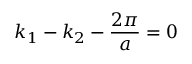Convert formula to latex. <formula><loc_0><loc_0><loc_500><loc_500>k _ { 1 } - k _ { 2 } - \frac { 2 \pi } { a } = 0</formula> 